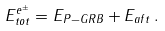<formula> <loc_0><loc_0><loc_500><loc_500>E ^ { e ^ { \pm } } _ { t o t } = E _ { P - G R B } + E _ { a f t } \, .</formula> 